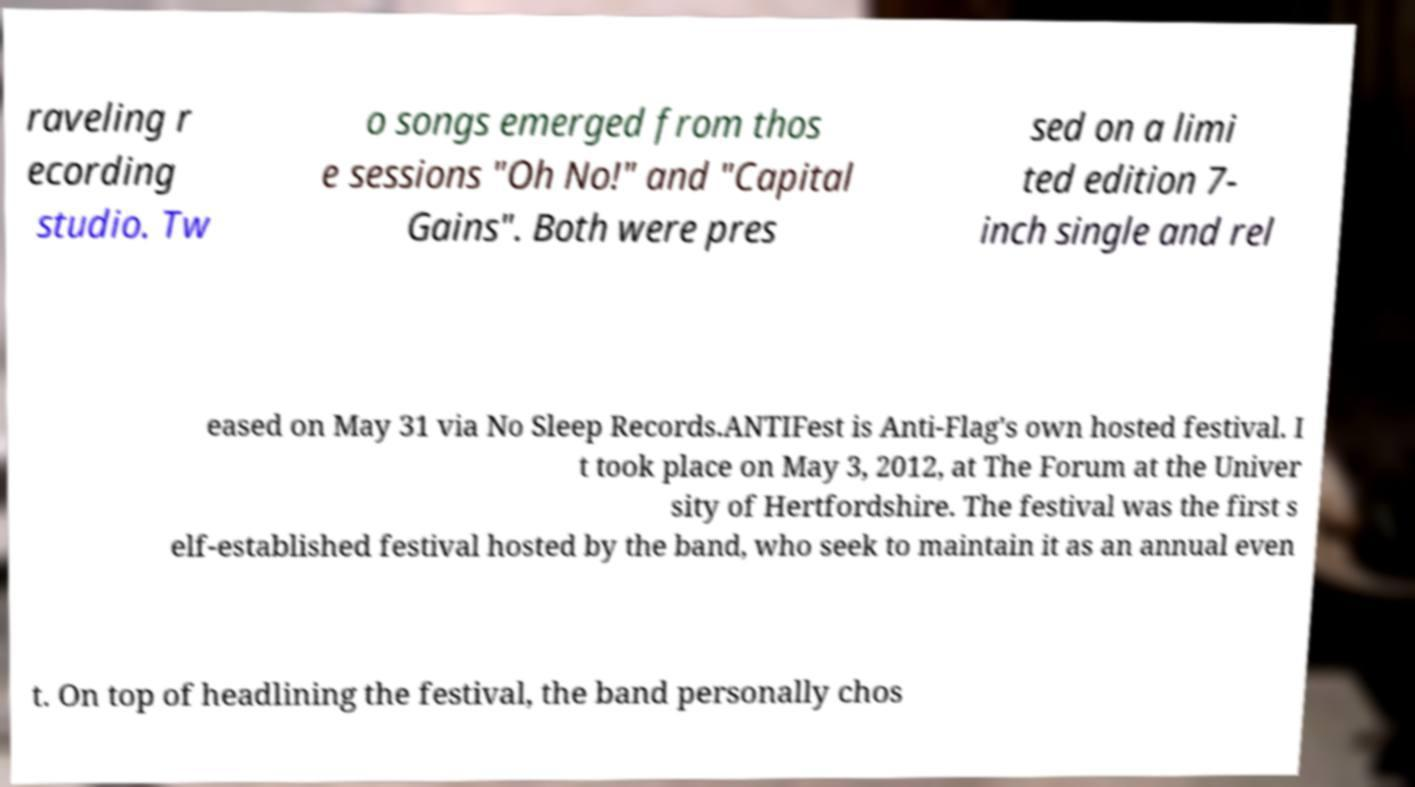Could you assist in decoding the text presented in this image and type it out clearly? raveling r ecording studio. Tw o songs emerged from thos e sessions "Oh No!" and "Capital Gains". Both were pres sed on a limi ted edition 7- inch single and rel eased on May 31 via No Sleep Records.ANTIFest is Anti-Flag's own hosted festival. I t took place on May 3, 2012, at The Forum at the Univer sity of Hertfordshire. The festival was the first s elf-established festival hosted by the band, who seek to maintain it as an annual even t. On top of headlining the festival, the band personally chos 